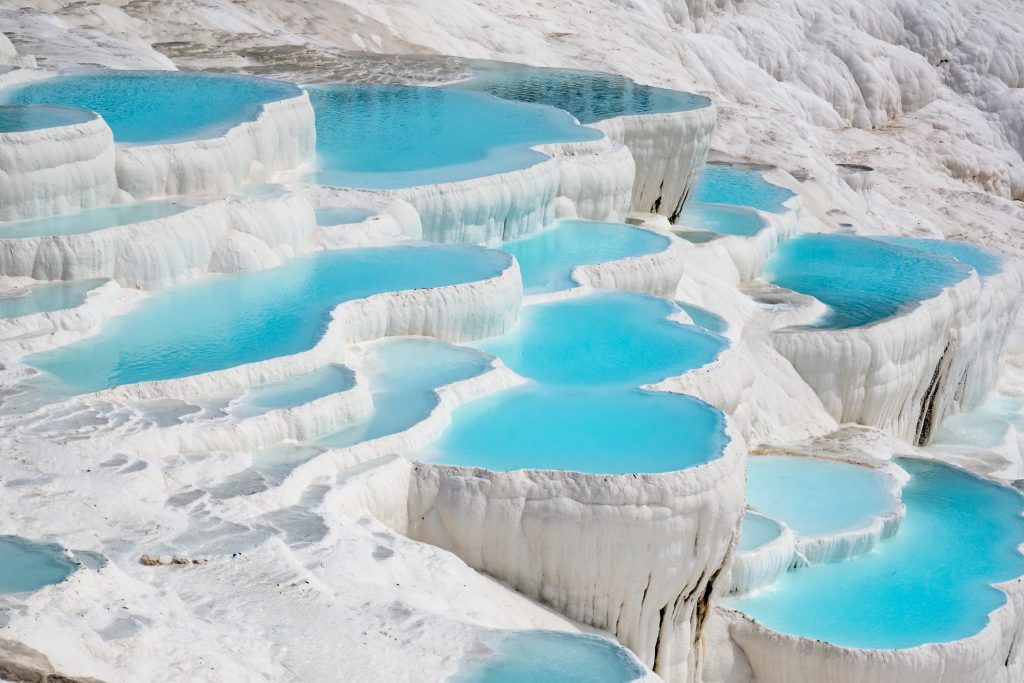Can you provide more details about the history and significance of Pamukkale? Pamukkale, which means 'Cotton Castle' in Turkish, has been a cherished natural spa and tourist attraction since ancient times. It is located in the Denizli Province in southwestern Turkey. The site's thermal springs have been used as a spa since the second century BC, attracting visitors from around the world. The historical significance of Pamukkale is intertwined with the nearby ancient city of Hierapolis, a UNESCO World Heritage site, founded as a thermal spa in the early 2nd century BC by the Attalid kings of Pergamum. Today, the remnants of Hierapolis, including its magnificent theater, necropolis, and well-preserved streets, provide a glimpse into its historical and cultural importance. 